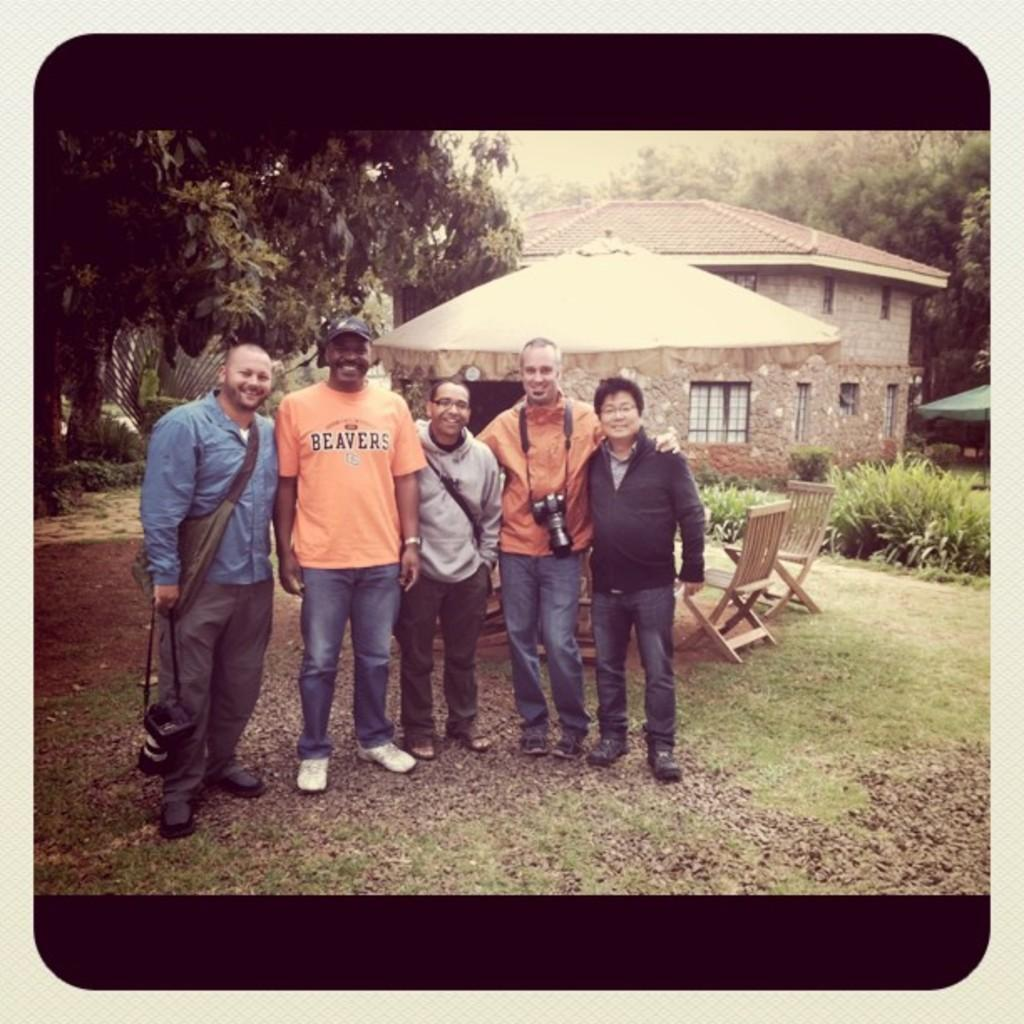How many people are in the image? There are people in the image, but the exact number is not specified. What is one person doing in the image? One person is holding a camera. What is unique about the clothing of another person in the image? Another person is wearing a camera. What type of furniture is present in the image? There are chairs in the image. What type of vegetation can be seen in the image? There are plants and trees in the image. What type of structures are visible in the image? There are houses in the image. Where is the boy sitting on the boot in the image? There is no boy or boot present in the image. What type of bomb can be seen in the image? There is no bomb present in the image. 